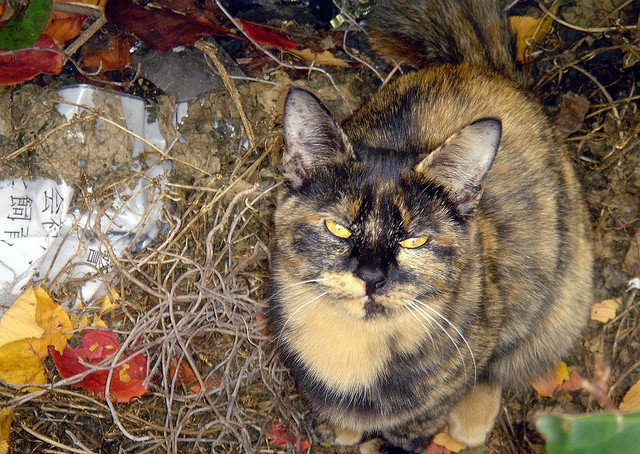Describe the objects in this image and their specific colors. I can see a cat in darkgreen, gray, tan, and black tones in this image. 